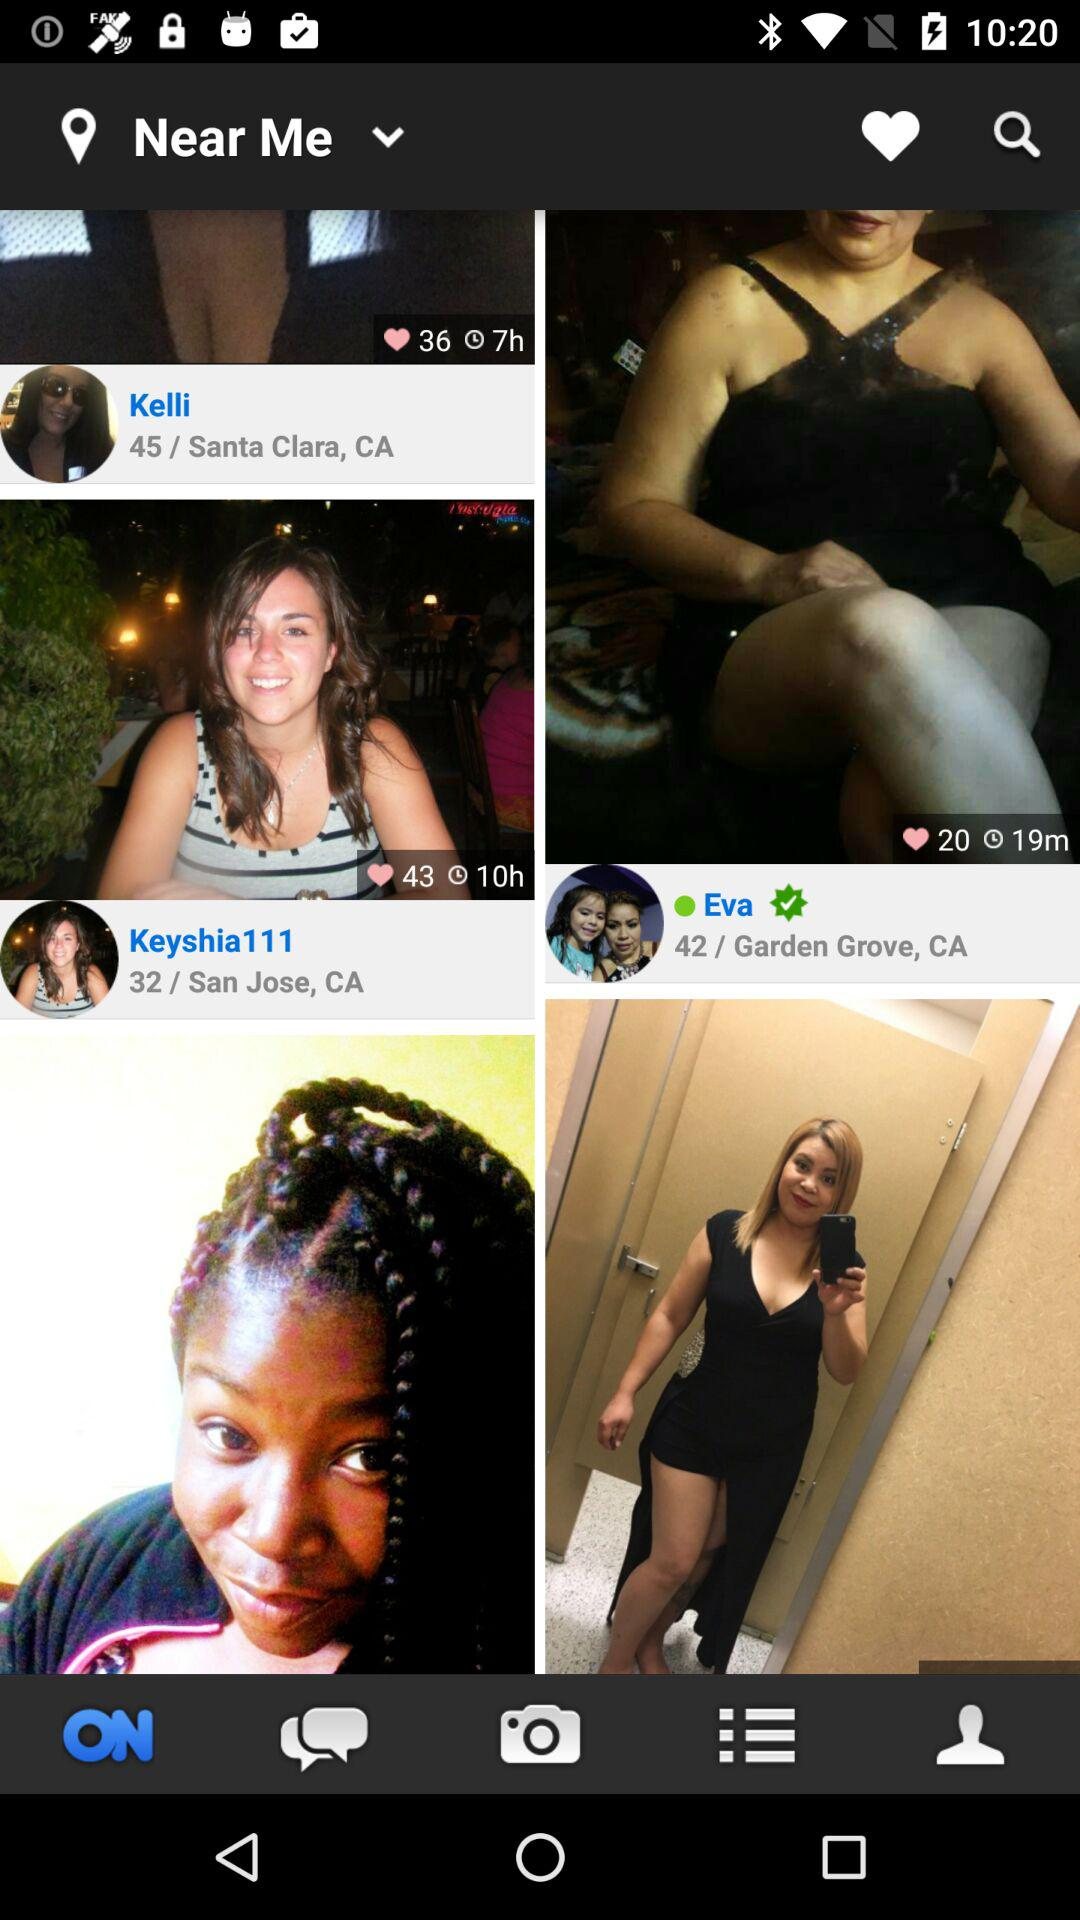What is the age of Keyshia111? The age of Keyshia111 is 32 years. 